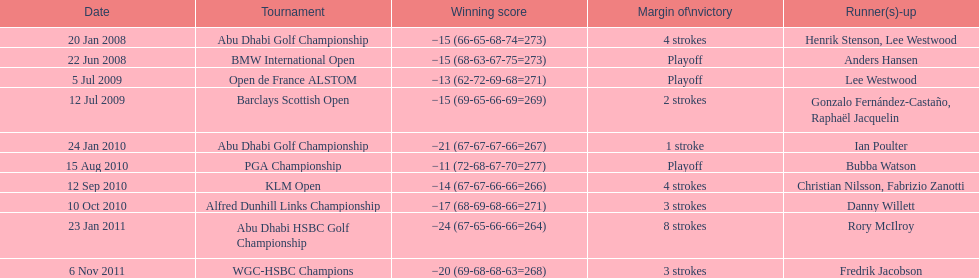How many tournaments has he won by 3 or more strokes? 5. 